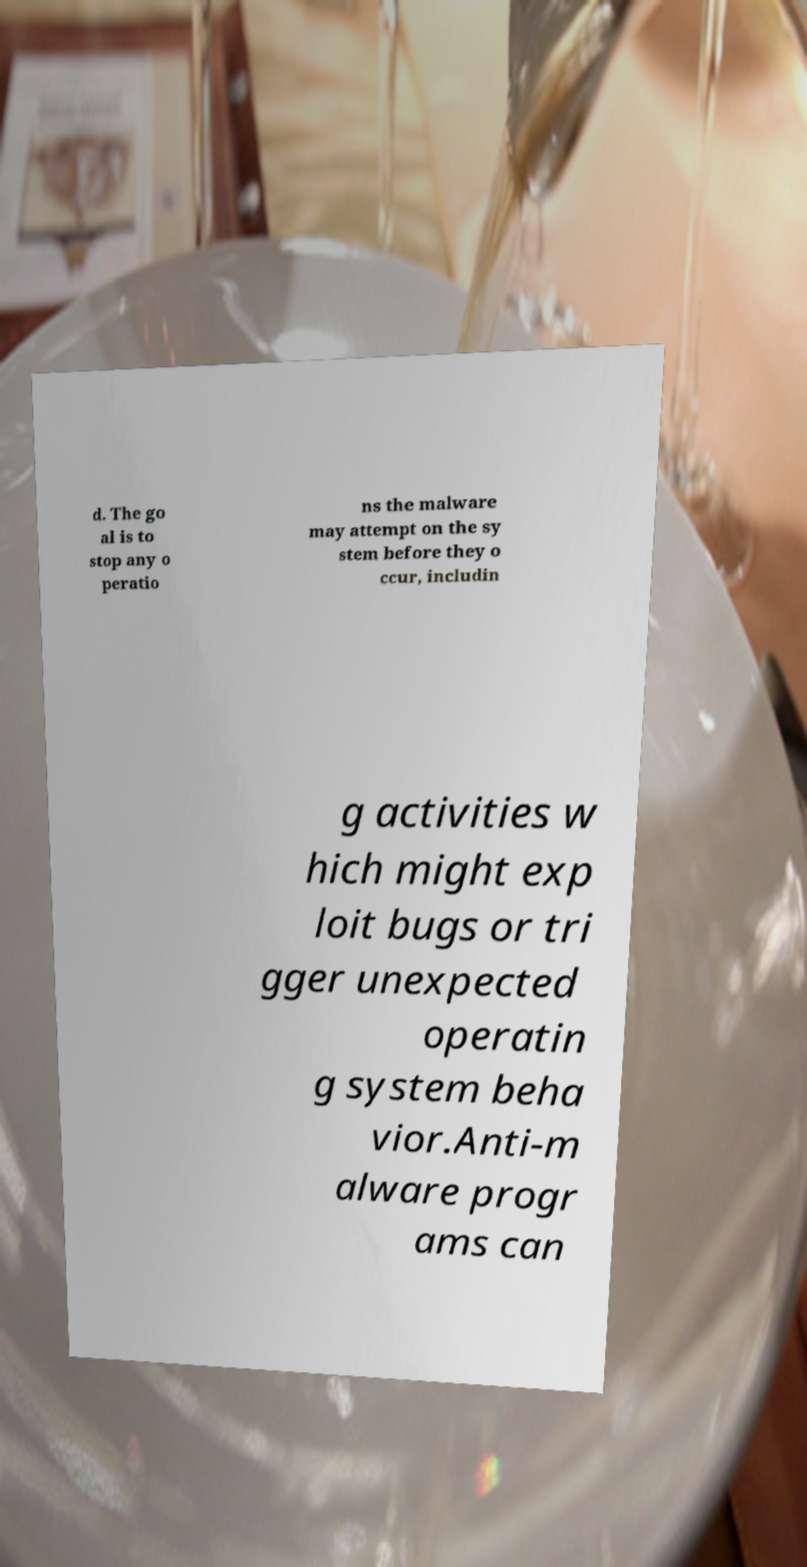What messages or text are displayed in this image? I need them in a readable, typed format. d. The go al is to stop any o peratio ns the malware may attempt on the sy stem before they o ccur, includin g activities w hich might exp loit bugs or tri gger unexpected operatin g system beha vior.Anti-m alware progr ams can 